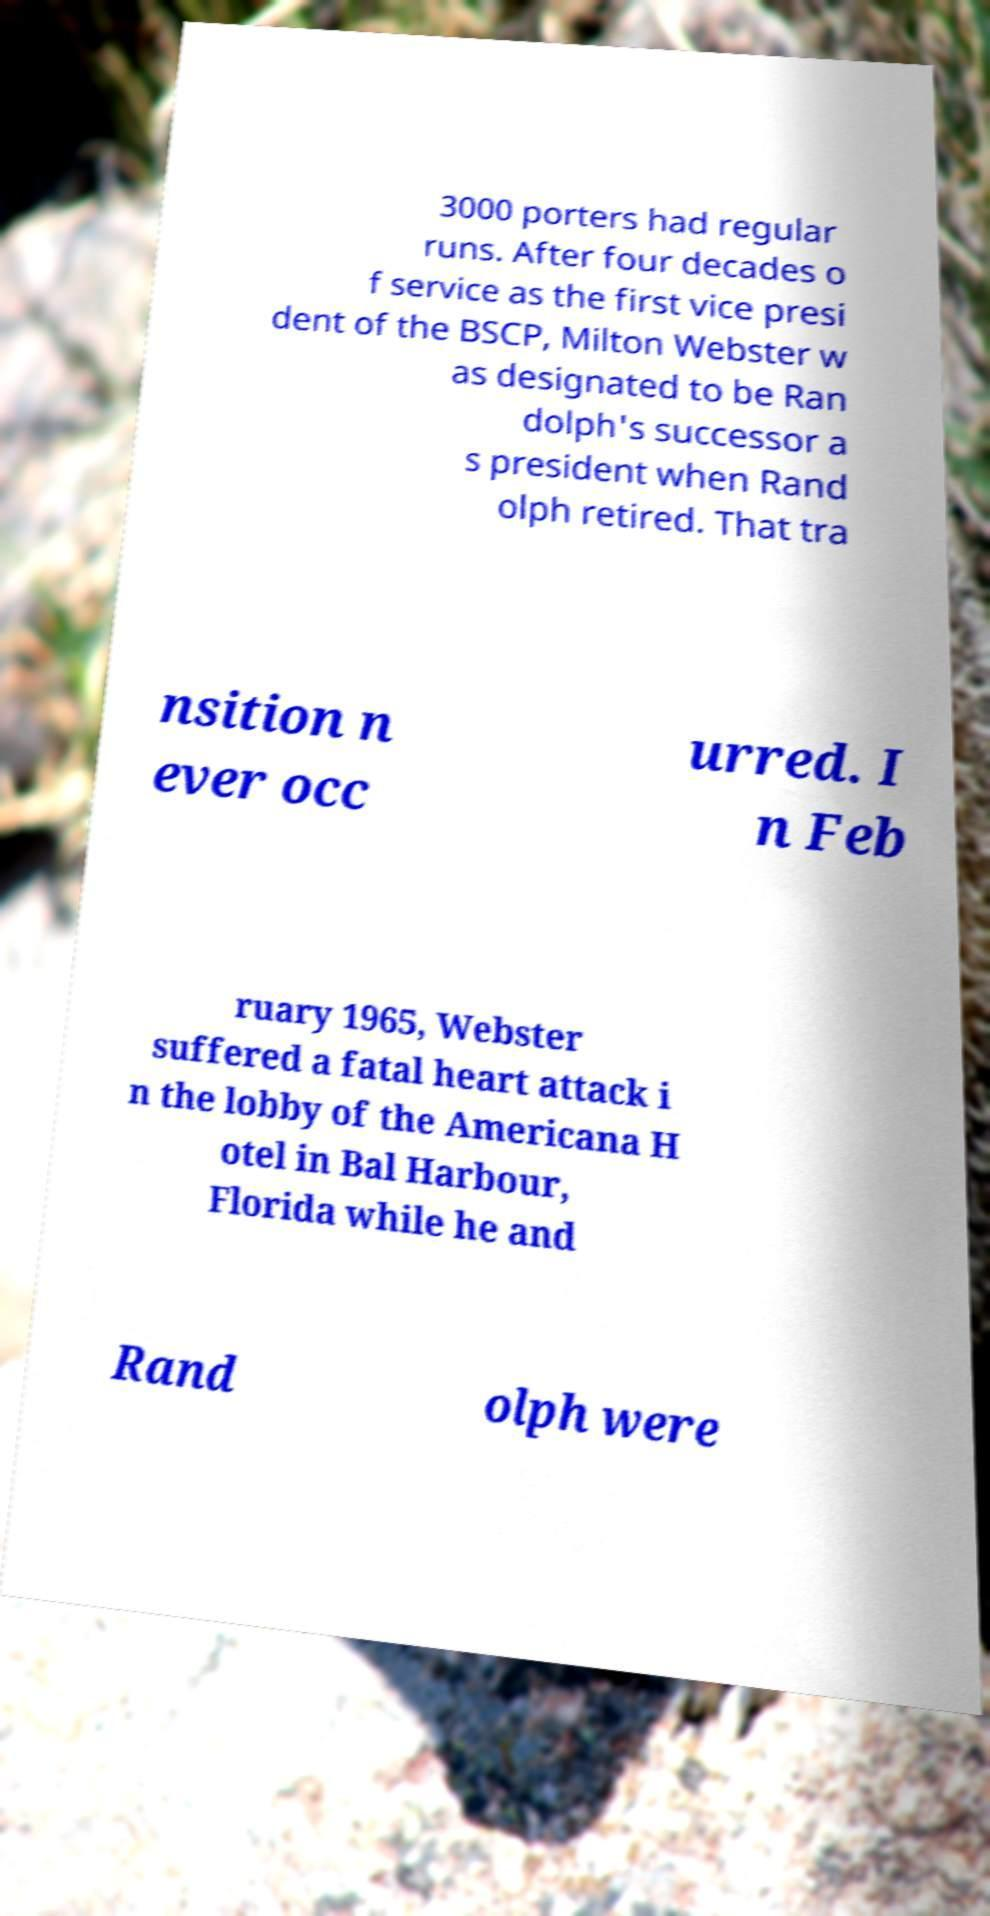Can you accurately transcribe the text from the provided image for me? 3000 porters had regular runs. After four decades o f service as the first vice presi dent of the BSCP, Milton Webster w as designated to be Ran dolph's successor a s president when Rand olph retired. That tra nsition n ever occ urred. I n Feb ruary 1965, Webster suffered a fatal heart attack i n the lobby of the Americana H otel in Bal Harbour, Florida while he and Rand olph were 